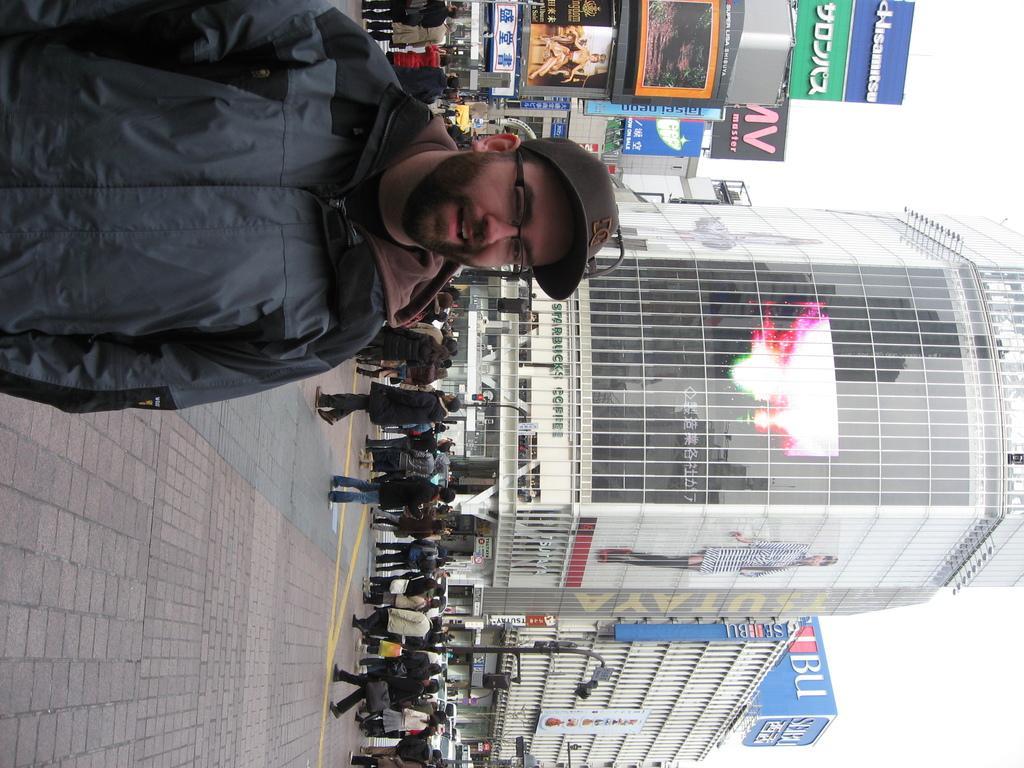In one or two sentences, can you explain what this image depicts? In this picture we can see a person, he is wearing a cap, spectacles and in the background we can see a group of people on the ground, here we can see buildings, name boards, electric poles and some objects. 